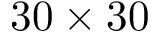<formula> <loc_0><loc_0><loc_500><loc_500>3 0 \times 3 0</formula> 